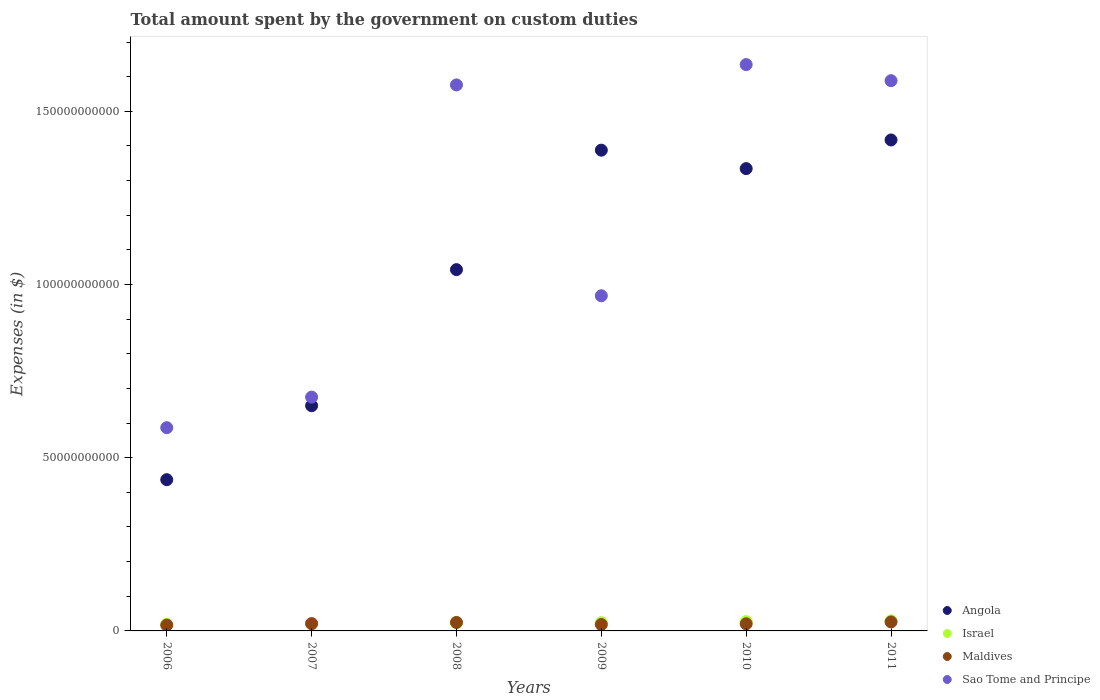How many different coloured dotlines are there?
Make the answer very short. 4. Is the number of dotlines equal to the number of legend labels?
Offer a terse response. Yes. What is the amount spent on custom duties by the government in Maldives in 2011?
Your answer should be very brief. 2.59e+09. Across all years, what is the maximum amount spent on custom duties by the government in Sao Tome and Principe?
Provide a succinct answer. 1.63e+11. Across all years, what is the minimum amount spent on custom duties by the government in Angola?
Your answer should be compact. 4.37e+1. In which year was the amount spent on custom duties by the government in Israel maximum?
Provide a short and direct response. 2011. What is the total amount spent on custom duties by the government in Maldives in the graph?
Make the answer very short. 1.27e+1. What is the difference between the amount spent on custom duties by the government in Israel in 2008 and that in 2011?
Offer a terse response. -5.37e+08. What is the difference between the amount spent on custom duties by the government in Israel in 2009 and the amount spent on custom duties by the government in Sao Tome and Principe in 2010?
Give a very brief answer. -1.61e+11. What is the average amount spent on custom duties by the government in Israel per year?
Give a very brief answer. 2.41e+09. In the year 2010, what is the difference between the amount spent on custom duties by the government in Angola and amount spent on custom duties by the government in Maldives?
Keep it short and to the point. 1.31e+11. What is the ratio of the amount spent on custom duties by the government in Maldives in 2007 to that in 2010?
Your response must be concise. 1.01. Is the difference between the amount spent on custom duties by the government in Angola in 2007 and 2010 greater than the difference between the amount spent on custom duties by the government in Maldives in 2007 and 2010?
Offer a very short reply. No. What is the difference between the highest and the second highest amount spent on custom duties by the government in Sao Tome and Principe?
Make the answer very short. 4.64e+09. What is the difference between the highest and the lowest amount spent on custom duties by the government in Israel?
Ensure brevity in your answer.  1.02e+09. Is the sum of the amount spent on custom duties by the government in Angola in 2007 and 2010 greater than the maximum amount spent on custom duties by the government in Sao Tome and Principe across all years?
Offer a terse response. Yes. Is it the case that in every year, the sum of the amount spent on custom duties by the government in Israel and amount spent on custom duties by the government in Sao Tome and Principe  is greater than the sum of amount spent on custom duties by the government in Maldives and amount spent on custom duties by the government in Angola?
Make the answer very short. Yes. Is it the case that in every year, the sum of the amount spent on custom duties by the government in Angola and amount spent on custom duties by the government in Sao Tome and Principe  is greater than the amount spent on custom duties by the government in Israel?
Ensure brevity in your answer.  Yes. Does the amount spent on custom duties by the government in Maldives monotonically increase over the years?
Provide a succinct answer. No. Is the amount spent on custom duties by the government in Sao Tome and Principe strictly less than the amount spent on custom duties by the government in Angola over the years?
Make the answer very short. No. What is the difference between two consecutive major ticks on the Y-axis?
Give a very brief answer. 5.00e+1. Does the graph contain grids?
Ensure brevity in your answer.  No. Where does the legend appear in the graph?
Your answer should be very brief. Bottom right. How are the legend labels stacked?
Your answer should be compact. Vertical. What is the title of the graph?
Offer a very short reply. Total amount spent by the government on custom duties. What is the label or title of the Y-axis?
Give a very brief answer. Expenses (in $). What is the Expenses (in $) of Angola in 2006?
Give a very brief answer. 4.37e+1. What is the Expenses (in $) in Israel in 2006?
Your response must be concise. 1.89e+09. What is the Expenses (in $) of Maldives in 2006?
Your answer should be compact. 1.68e+09. What is the Expenses (in $) in Sao Tome and Principe in 2006?
Your answer should be compact. 5.87e+1. What is the Expenses (in $) in Angola in 2007?
Offer a terse response. 6.50e+1. What is the Expenses (in $) of Israel in 2007?
Ensure brevity in your answer.  2.22e+09. What is the Expenses (in $) of Maldives in 2007?
Your response must be concise. 2.09e+09. What is the Expenses (in $) of Sao Tome and Principe in 2007?
Give a very brief answer. 6.75e+1. What is the Expenses (in $) in Angola in 2008?
Offer a very short reply. 1.04e+11. What is the Expenses (in $) of Israel in 2008?
Keep it short and to the point. 2.38e+09. What is the Expenses (in $) in Maldives in 2008?
Offer a terse response. 2.45e+09. What is the Expenses (in $) of Sao Tome and Principe in 2008?
Your answer should be very brief. 1.58e+11. What is the Expenses (in $) in Angola in 2009?
Your response must be concise. 1.39e+11. What is the Expenses (in $) of Israel in 2009?
Your response must be concise. 2.40e+09. What is the Expenses (in $) in Maldives in 2009?
Offer a very short reply. 1.85e+09. What is the Expenses (in $) in Sao Tome and Principe in 2009?
Your response must be concise. 9.67e+1. What is the Expenses (in $) of Angola in 2010?
Offer a very short reply. 1.33e+11. What is the Expenses (in $) of Israel in 2010?
Your response must be concise. 2.69e+09. What is the Expenses (in $) of Maldives in 2010?
Offer a terse response. 2.06e+09. What is the Expenses (in $) in Sao Tome and Principe in 2010?
Ensure brevity in your answer.  1.63e+11. What is the Expenses (in $) in Angola in 2011?
Provide a succinct answer. 1.42e+11. What is the Expenses (in $) in Israel in 2011?
Provide a short and direct response. 2.91e+09. What is the Expenses (in $) of Maldives in 2011?
Offer a very short reply. 2.59e+09. What is the Expenses (in $) in Sao Tome and Principe in 2011?
Keep it short and to the point. 1.59e+11. Across all years, what is the maximum Expenses (in $) in Angola?
Offer a very short reply. 1.42e+11. Across all years, what is the maximum Expenses (in $) of Israel?
Offer a terse response. 2.91e+09. Across all years, what is the maximum Expenses (in $) of Maldives?
Keep it short and to the point. 2.59e+09. Across all years, what is the maximum Expenses (in $) of Sao Tome and Principe?
Offer a terse response. 1.63e+11. Across all years, what is the minimum Expenses (in $) of Angola?
Provide a succinct answer. 4.37e+1. Across all years, what is the minimum Expenses (in $) of Israel?
Provide a succinct answer. 1.89e+09. Across all years, what is the minimum Expenses (in $) in Maldives?
Your response must be concise. 1.68e+09. Across all years, what is the minimum Expenses (in $) in Sao Tome and Principe?
Keep it short and to the point. 5.87e+1. What is the total Expenses (in $) of Angola in the graph?
Make the answer very short. 6.27e+11. What is the total Expenses (in $) in Israel in the graph?
Offer a very short reply. 1.45e+1. What is the total Expenses (in $) in Maldives in the graph?
Make the answer very short. 1.27e+1. What is the total Expenses (in $) in Sao Tome and Principe in the graph?
Your response must be concise. 7.03e+11. What is the difference between the Expenses (in $) of Angola in 2006 and that in 2007?
Offer a very short reply. -2.13e+1. What is the difference between the Expenses (in $) in Israel in 2006 and that in 2007?
Your response must be concise. -3.21e+08. What is the difference between the Expenses (in $) of Maldives in 2006 and that in 2007?
Offer a terse response. -4.02e+08. What is the difference between the Expenses (in $) of Sao Tome and Principe in 2006 and that in 2007?
Give a very brief answer. -8.83e+09. What is the difference between the Expenses (in $) in Angola in 2006 and that in 2008?
Offer a terse response. -6.06e+1. What is the difference between the Expenses (in $) in Israel in 2006 and that in 2008?
Give a very brief answer. -4.81e+08. What is the difference between the Expenses (in $) in Maldives in 2006 and that in 2008?
Provide a short and direct response. -7.65e+08. What is the difference between the Expenses (in $) of Sao Tome and Principe in 2006 and that in 2008?
Your answer should be very brief. -9.89e+1. What is the difference between the Expenses (in $) of Angola in 2006 and that in 2009?
Offer a very short reply. -9.51e+1. What is the difference between the Expenses (in $) of Israel in 2006 and that in 2009?
Give a very brief answer. -5.08e+08. What is the difference between the Expenses (in $) of Maldives in 2006 and that in 2009?
Ensure brevity in your answer.  -1.65e+08. What is the difference between the Expenses (in $) in Sao Tome and Principe in 2006 and that in 2009?
Offer a terse response. -3.81e+1. What is the difference between the Expenses (in $) of Angola in 2006 and that in 2010?
Your response must be concise. -8.98e+1. What is the difference between the Expenses (in $) in Israel in 2006 and that in 2010?
Your answer should be compact. -7.95e+08. What is the difference between the Expenses (in $) in Maldives in 2006 and that in 2010?
Offer a terse response. -3.72e+08. What is the difference between the Expenses (in $) in Sao Tome and Principe in 2006 and that in 2010?
Give a very brief answer. -1.05e+11. What is the difference between the Expenses (in $) in Angola in 2006 and that in 2011?
Keep it short and to the point. -9.81e+1. What is the difference between the Expenses (in $) in Israel in 2006 and that in 2011?
Give a very brief answer. -1.02e+09. What is the difference between the Expenses (in $) in Maldives in 2006 and that in 2011?
Your answer should be compact. -9.02e+08. What is the difference between the Expenses (in $) in Sao Tome and Principe in 2006 and that in 2011?
Offer a very short reply. -1.00e+11. What is the difference between the Expenses (in $) in Angola in 2007 and that in 2008?
Provide a succinct answer. -3.93e+1. What is the difference between the Expenses (in $) of Israel in 2007 and that in 2008?
Make the answer very short. -1.60e+08. What is the difference between the Expenses (in $) of Maldives in 2007 and that in 2008?
Your answer should be very brief. -3.62e+08. What is the difference between the Expenses (in $) in Sao Tome and Principe in 2007 and that in 2008?
Offer a terse response. -9.01e+1. What is the difference between the Expenses (in $) in Angola in 2007 and that in 2009?
Provide a succinct answer. -7.38e+1. What is the difference between the Expenses (in $) of Israel in 2007 and that in 2009?
Provide a short and direct response. -1.87e+08. What is the difference between the Expenses (in $) of Maldives in 2007 and that in 2009?
Your answer should be compact. 2.38e+08. What is the difference between the Expenses (in $) of Sao Tome and Principe in 2007 and that in 2009?
Offer a terse response. -2.93e+1. What is the difference between the Expenses (in $) in Angola in 2007 and that in 2010?
Keep it short and to the point. -6.84e+1. What is the difference between the Expenses (in $) of Israel in 2007 and that in 2010?
Your answer should be very brief. -4.74e+08. What is the difference between the Expenses (in $) of Maldives in 2007 and that in 2010?
Offer a terse response. 3.07e+07. What is the difference between the Expenses (in $) in Sao Tome and Principe in 2007 and that in 2010?
Keep it short and to the point. -9.60e+1. What is the difference between the Expenses (in $) in Angola in 2007 and that in 2011?
Your answer should be very brief. -7.67e+1. What is the difference between the Expenses (in $) in Israel in 2007 and that in 2011?
Your response must be concise. -6.97e+08. What is the difference between the Expenses (in $) in Maldives in 2007 and that in 2011?
Your answer should be compact. -5.00e+08. What is the difference between the Expenses (in $) in Sao Tome and Principe in 2007 and that in 2011?
Provide a short and direct response. -9.13e+1. What is the difference between the Expenses (in $) of Angola in 2008 and that in 2009?
Give a very brief answer. -3.45e+1. What is the difference between the Expenses (in $) of Israel in 2008 and that in 2009?
Keep it short and to the point. -2.70e+07. What is the difference between the Expenses (in $) in Maldives in 2008 and that in 2009?
Provide a short and direct response. 6.00e+08. What is the difference between the Expenses (in $) of Sao Tome and Principe in 2008 and that in 2009?
Provide a short and direct response. 6.09e+1. What is the difference between the Expenses (in $) in Angola in 2008 and that in 2010?
Provide a succinct answer. -2.92e+1. What is the difference between the Expenses (in $) in Israel in 2008 and that in 2010?
Provide a short and direct response. -3.14e+08. What is the difference between the Expenses (in $) in Maldives in 2008 and that in 2010?
Your answer should be compact. 3.93e+08. What is the difference between the Expenses (in $) in Sao Tome and Principe in 2008 and that in 2010?
Your answer should be compact. -5.86e+09. What is the difference between the Expenses (in $) in Angola in 2008 and that in 2011?
Provide a succinct answer. -3.74e+1. What is the difference between the Expenses (in $) in Israel in 2008 and that in 2011?
Provide a short and direct response. -5.37e+08. What is the difference between the Expenses (in $) of Maldives in 2008 and that in 2011?
Give a very brief answer. -1.38e+08. What is the difference between the Expenses (in $) in Sao Tome and Principe in 2008 and that in 2011?
Your answer should be compact. -1.22e+09. What is the difference between the Expenses (in $) in Angola in 2009 and that in 2010?
Provide a short and direct response. 5.33e+09. What is the difference between the Expenses (in $) of Israel in 2009 and that in 2010?
Offer a terse response. -2.87e+08. What is the difference between the Expenses (in $) in Maldives in 2009 and that in 2010?
Your answer should be compact. -2.07e+08. What is the difference between the Expenses (in $) in Sao Tome and Principe in 2009 and that in 2010?
Offer a very short reply. -6.67e+1. What is the difference between the Expenses (in $) in Angola in 2009 and that in 2011?
Your answer should be compact. -2.95e+09. What is the difference between the Expenses (in $) of Israel in 2009 and that in 2011?
Give a very brief answer. -5.10e+08. What is the difference between the Expenses (in $) in Maldives in 2009 and that in 2011?
Keep it short and to the point. -7.38e+08. What is the difference between the Expenses (in $) of Sao Tome and Principe in 2009 and that in 2011?
Your response must be concise. -6.21e+1. What is the difference between the Expenses (in $) of Angola in 2010 and that in 2011?
Your answer should be very brief. -8.27e+09. What is the difference between the Expenses (in $) of Israel in 2010 and that in 2011?
Offer a very short reply. -2.23e+08. What is the difference between the Expenses (in $) of Maldives in 2010 and that in 2011?
Make the answer very short. -5.31e+08. What is the difference between the Expenses (in $) in Sao Tome and Principe in 2010 and that in 2011?
Ensure brevity in your answer.  4.64e+09. What is the difference between the Expenses (in $) of Angola in 2006 and the Expenses (in $) of Israel in 2007?
Ensure brevity in your answer.  4.14e+1. What is the difference between the Expenses (in $) of Angola in 2006 and the Expenses (in $) of Maldives in 2007?
Give a very brief answer. 4.16e+1. What is the difference between the Expenses (in $) in Angola in 2006 and the Expenses (in $) in Sao Tome and Principe in 2007?
Ensure brevity in your answer.  -2.38e+1. What is the difference between the Expenses (in $) of Israel in 2006 and the Expenses (in $) of Maldives in 2007?
Give a very brief answer. -1.92e+08. What is the difference between the Expenses (in $) in Israel in 2006 and the Expenses (in $) in Sao Tome and Principe in 2007?
Offer a terse response. -6.56e+1. What is the difference between the Expenses (in $) of Maldives in 2006 and the Expenses (in $) of Sao Tome and Principe in 2007?
Your response must be concise. -6.58e+1. What is the difference between the Expenses (in $) of Angola in 2006 and the Expenses (in $) of Israel in 2008?
Your answer should be very brief. 4.13e+1. What is the difference between the Expenses (in $) in Angola in 2006 and the Expenses (in $) in Maldives in 2008?
Provide a short and direct response. 4.12e+1. What is the difference between the Expenses (in $) of Angola in 2006 and the Expenses (in $) of Sao Tome and Principe in 2008?
Keep it short and to the point. -1.14e+11. What is the difference between the Expenses (in $) of Israel in 2006 and the Expenses (in $) of Maldives in 2008?
Provide a succinct answer. -5.55e+08. What is the difference between the Expenses (in $) of Israel in 2006 and the Expenses (in $) of Sao Tome and Principe in 2008?
Provide a succinct answer. -1.56e+11. What is the difference between the Expenses (in $) in Maldives in 2006 and the Expenses (in $) in Sao Tome and Principe in 2008?
Your answer should be compact. -1.56e+11. What is the difference between the Expenses (in $) in Angola in 2006 and the Expenses (in $) in Israel in 2009?
Ensure brevity in your answer.  4.13e+1. What is the difference between the Expenses (in $) of Angola in 2006 and the Expenses (in $) of Maldives in 2009?
Provide a succinct answer. 4.18e+1. What is the difference between the Expenses (in $) in Angola in 2006 and the Expenses (in $) in Sao Tome and Principe in 2009?
Your answer should be compact. -5.31e+1. What is the difference between the Expenses (in $) of Israel in 2006 and the Expenses (in $) of Maldives in 2009?
Give a very brief answer. 4.52e+07. What is the difference between the Expenses (in $) of Israel in 2006 and the Expenses (in $) of Sao Tome and Principe in 2009?
Your answer should be compact. -9.49e+1. What is the difference between the Expenses (in $) of Maldives in 2006 and the Expenses (in $) of Sao Tome and Principe in 2009?
Keep it short and to the point. -9.51e+1. What is the difference between the Expenses (in $) in Angola in 2006 and the Expenses (in $) in Israel in 2010?
Give a very brief answer. 4.10e+1. What is the difference between the Expenses (in $) in Angola in 2006 and the Expenses (in $) in Maldives in 2010?
Offer a terse response. 4.16e+1. What is the difference between the Expenses (in $) in Angola in 2006 and the Expenses (in $) in Sao Tome and Principe in 2010?
Offer a very short reply. -1.20e+11. What is the difference between the Expenses (in $) in Israel in 2006 and the Expenses (in $) in Maldives in 2010?
Provide a succinct answer. -1.62e+08. What is the difference between the Expenses (in $) of Israel in 2006 and the Expenses (in $) of Sao Tome and Principe in 2010?
Provide a short and direct response. -1.62e+11. What is the difference between the Expenses (in $) of Maldives in 2006 and the Expenses (in $) of Sao Tome and Principe in 2010?
Offer a terse response. -1.62e+11. What is the difference between the Expenses (in $) in Angola in 2006 and the Expenses (in $) in Israel in 2011?
Offer a terse response. 4.07e+1. What is the difference between the Expenses (in $) of Angola in 2006 and the Expenses (in $) of Maldives in 2011?
Give a very brief answer. 4.11e+1. What is the difference between the Expenses (in $) in Angola in 2006 and the Expenses (in $) in Sao Tome and Principe in 2011?
Offer a very short reply. -1.15e+11. What is the difference between the Expenses (in $) of Israel in 2006 and the Expenses (in $) of Maldives in 2011?
Your answer should be compact. -6.92e+08. What is the difference between the Expenses (in $) of Israel in 2006 and the Expenses (in $) of Sao Tome and Principe in 2011?
Provide a short and direct response. -1.57e+11. What is the difference between the Expenses (in $) of Maldives in 2006 and the Expenses (in $) of Sao Tome and Principe in 2011?
Make the answer very short. -1.57e+11. What is the difference between the Expenses (in $) of Angola in 2007 and the Expenses (in $) of Israel in 2008?
Your response must be concise. 6.26e+1. What is the difference between the Expenses (in $) of Angola in 2007 and the Expenses (in $) of Maldives in 2008?
Your response must be concise. 6.26e+1. What is the difference between the Expenses (in $) in Angola in 2007 and the Expenses (in $) in Sao Tome and Principe in 2008?
Your answer should be compact. -9.26e+1. What is the difference between the Expenses (in $) in Israel in 2007 and the Expenses (in $) in Maldives in 2008?
Keep it short and to the point. -2.34e+08. What is the difference between the Expenses (in $) in Israel in 2007 and the Expenses (in $) in Sao Tome and Principe in 2008?
Offer a terse response. -1.55e+11. What is the difference between the Expenses (in $) of Maldives in 2007 and the Expenses (in $) of Sao Tome and Principe in 2008?
Keep it short and to the point. -1.56e+11. What is the difference between the Expenses (in $) of Angola in 2007 and the Expenses (in $) of Israel in 2009?
Your answer should be very brief. 6.26e+1. What is the difference between the Expenses (in $) of Angola in 2007 and the Expenses (in $) of Maldives in 2009?
Ensure brevity in your answer.  6.32e+1. What is the difference between the Expenses (in $) in Angola in 2007 and the Expenses (in $) in Sao Tome and Principe in 2009?
Give a very brief answer. -3.17e+1. What is the difference between the Expenses (in $) of Israel in 2007 and the Expenses (in $) of Maldives in 2009?
Give a very brief answer. 3.66e+08. What is the difference between the Expenses (in $) in Israel in 2007 and the Expenses (in $) in Sao Tome and Principe in 2009?
Make the answer very short. -9.45e+1. What is the difference between the Expenses (in $) of Maldives in 2007 and the Expenses (in $) of Sao Tome and Principe in 2009?
Offer a very short reply. -9.47e+1. What is the difference between the Expenses (in $) of Angola in 2007 and the Expenses (in $) of Israel in 2010?
Ensure brevity in your answer.  6.23e+1. What is the difference between the Expenses (in $) of Angola in 2007 and the Expenses (in $) of Maldives in 2010?
Your answer should be very brief. 6.30e+1. What is the difference between the Expenses (in $) in Angola in 2007 and the Expenses (in $) in Sao Tome and Principe in 2010?
Your response must be concise. -9.85e+1. What is the difference between the Expenses (in $) of Israel in 2007 and the Expenses (in $) of Maldives in 2010?
Ensure brevity in your answer.  1.59e+08. What is the difference between the Expenses (in $) in Israel in 2007 and the Expenses (in $) in Sao Tome and Principe in 2010?
Make the answer very short. -1.61e+11. What is the difference between the Expenses (in $) in Maldives in 2007 and the Expenses (in $) in Sao Tome and Principe in 2010?
Offer a very short reply. -1.61e+11. What is the difference between the Expenses (in $) in Angola in 2007 and the Expenses (in $) in Israel in 2011?
Your response must be concise. 6.21e+1. What is the difference between the Expenses (in $) in Angola in 2007 and the Expenses (in $) in Maldives in 2011?
Make the answer very short. 6.24e+1. What is the difference between the Expenses (in $) of Angola in 2007 and the Expenses (in $) of Sao Tome and Principe in 2011?
Make the answer very short. -9.38e+1. What is the difference between the Expenses (in $) of Israel in 2007 and the Expenses (in $) of Maldives in 2011?
Provide a succinct answer. -3.72e+08. What is the difference between the Expenses (in $) in Israel in 2007 and the Expenses (in $) in Sao Tome and Principe in 2011?
Offer a very short reply. -1.57e+11. What is the difference between the Expenses (in $) of Maldives in 2007 and the Expenses (in $) of Sao Tome and Principe in 2011?
Provide a succinct answer. -1.57e+11. What is the difference between the Expenses (in $) in Angola in 2008 and the Expenses (in $) in Israel in 2009?
Keep it short and to the point. 1.02e+11. What is the difference between the Expenses (in $) in Angola in 2008 and the Expenses (in $) in Maldives in 2009?
Give a very brief answer. 1.02e+11. What is the difference between the Expenses (in $) in Angola in 2008 and the Expenses (in $) in Sao Tome and Principe in 2009?
Your response must be concise. 7.54e+09. What is the difference between the Expenses (in $) in Israel in 2008 and the Expenses (in $) in Maldives in 2009?
Offer a terse response. 5.26e+08. What is the difference between the Expenses (in $) in Israel in 2008 and the Expenses (in $) in Sao Tome and Principe in 2009?
Your answer should be very brief. -9.44e+1. What is the difference between the Expenses (in $) of Maldives in 2008 and the Expenses (in $) of Sao Tome and Principe in 2009?
Provide a short and direct response. -9.43e+1. What is the difference between the Expenses (in $) of Angola in 2008 and the Expenses (in $) of Israel in 2010?
Make the answer very short. 1.02e+11. What is the difference between the Expenses (in $) in Angola in 2008 and the Expenses (in $) in Maldives in 2010?
Offer a very short reply. 1.02e+11. What is the difference between the Expenses (in $) of Angola in 2008 and the Expenses (in $) of Sao Tome and Principe in 2010?
Your response must be concise. -5.92e+1. What is the difference between the Expenses (in $) in Israel in 2008 and the Expenses (in $) in Maldives in 2010?
Keep it short and to the point. 3.19e+08. What is the difference between the Expenses (in $) of Israel in 2008 and the Expenses (in $) of Sao Tome and Principe in 2010?
Offer a terse response. -1.61e+11. What is the difference between the Expenses (in $) of Maldives in 2008 and the Expenses (in $) of Sao Tome and Principe in 2010?
Offer a terse response. -1.61e+11. What is the difference between the Expenses (in $) of Angola in 2008 and the Expenses (in $) of Israel in 2011?
Make the answer very short. 1.01e+11. What is the difference between the Expenses (in $) of Angola in 2008 and the Expenses (in $) of Maldives in 2011?
Keep it short and to the point. 1.02e+11. What is the difference between the Expenses (in $) in Angola in 2008 and the Expenses (in $) in Sao Tome and Principe in 2011?
Make the answer very short. -5.45e+1. What is the difference between the Expenses (in $) in Israel in 2008 and the Expenses (in $) in Maldives in 2011?
Offer a very short reply. -2.12e+08. What is the difference between the Expenses (in $) of Israel in 2008 and the Expenses (in $) of Sao Tome and Principe in 2011?
Offer a very short reply. -1.56e+11. What is the difference between the Expenses (in $) of Maldives in 2008 and the Expenses (in $) of Sao Tome and Principe in 2011?
Your answer should be very brief. -1.56e+11. What is the difference between the Expenses (in $) in Angola in 2009 and the Expenses (in $) in Israel in 2010?
Provide a succinct answer. 1.36e+11. What is the difference between the Expenses (in $) of Angola in 2009 and the Expenses (in $) of Maldives in 2010?
Give a very brief answer. 1.37e+11. What is the difference between the Expenses (in $) of Angola in 2009 and the Expenses (in $) of Sao Tome and Principe in 2010?
Provide a succinct answer. -2.47e+1. What is the difference between the Expenses (in $) in Israel in 2009 and the Expenses (in $) in Maldives in 2010?
Your answer should be very brief. 3.46e+08. What is the difference between the Expenses (in $) of Israel in 2009 and the Expenses (in $) of Sao Tome and Principe in 2010?
Ensure brevity in your answer.  -1.61e+11. What is the difference between the Expenses (in $) in Maldives in 2009 and the Expenses (in $) in Sao Tome and Principe in 2010?
Your response must be concise. -1.62e+11. What is the difference between the Expenses (in $) of Angola in 2009 and the Expenses (in $) of Israel in 2011?
Give a very brief answer. 1.36e+11. What is the difference between the Expenses (in $) in Angola in 2009 and the Expenses (in $) in Maldives in 2011?
Ensure brevity in your answer.  1.36e+11. What is the difference between the Expenses (in $) of Angola in 2009 and the Expenses (in $) of Sao Tome and Principe in 2011?
Provide a succinct answer. -2.01e+1. What is the difference between the Expenses (in $) in Israel in 2009 and the Expenses (in $) in Maldives in 2011?
Offer a very short reply. -1.84e+08. What is the difference between the Expenses (in $) in Israel in 2009 and the Expenses (in $) in Sao Tome and Principe in 2011?
Keep it short and to the point. -1.56e+11. What is the difference between the Expenses (in $) in Maldives in 2009 and the Expenses (in $) in Sao Tome and Principe in 2011?
Make the answer very short. -1.57e+11. What is the difference between the Expenses (in $) in Angola in 2010 and the Expenses (in $) in Israel in 2011?
Ensure brevity in your answer.  1.31e+11. What is the difference between the Expenses (in $) in Angola in 2010 and the Expenses (in $) in Maldives in 2011?
Your answer should be compact. 1.31e+11. What is the difference between the Expenses (in $) in Angola in 2010 and the Expenses (in $) in Sao Tome and Principe in 2011?
Make the answer very short. -2.54e+1. What is the difference between the Expenses (in $) of Israel in 2010 and the Expenses (in $) of Maldives in 2011?
Your response must be concise. 1.02e+08. What is the difference between the Expenses (in $) of Israel in 2010 and the Expenses (in $) of Sao Tome and Principe in 2011?
Provide a short and direct response. -1.56e+11. What is the difference between the Expenses (in $) in Maldives in 2010 and the Expenses (in $) in Sao Tome and Principe in 2011?
Offer a terse response. -1.57e+11. What is the average Expenses (in $) in Angola per year?
Offer a very short reply. 1.04e+11. What is the average Expenses (in $) of Israel per year?
Your answer should be compact. 2.41e+09. What is the average Expenses (in $) of Maldives per year?
Give a very brief answer. 2.12e+09. What is the average Expenses (in $) of Sao Tome and Principe per year?
Provide a short and direct response. 1.17e+11. In the year 2006, what is the difference between the Expenses (in $) in Angola and Expenses (in $) in Israel?
Your answer should be very brief. 4.18e+1. In the year 2006, what is the difference between the Expenses (in $) in Angola and Expenses (in $) in Maldives?
Provide a succinct answer. 4.20e+1. In the year 2006, what is the difference between the Expenses (in $) in Angola and Expenses (in $) in Sao Tome and Principe?
Provide a succinct answer. -1.50e+1. In the year 2006, what is the difference between the Expenses (in $) of Israel and Expenses (in $) of Maldives?
Offer a terse response. 2.10e+08. In the year 2006, what is the difference between the Expenses (in $) in Israel and Expenses (in $) in Sao Tome and Principe?
Your response must be concise. -5.68e+1. In the year 2006, what is the difference between the Expenses (in $) of Maldives and Expenses (in $) of Sao Tome and Principe?
Offer a very short reply. -5.70e+1. In the year 2007, what is the difference between the Expenses (in $) of Angola and Expenses (in $) of Israel?
Make the answer very short. 6.28e+1. In the year 2007, what is the difference between the Expenses (in $) in Angola and Expenses (in $) in Maldives?
Your answer should be very brief. 6.29e+1. In the year 2007, what is the difference between the Expenses (in $) of Angola and Expenses (in $) of Sao Tome and Principe?
Ensure brevity in your answer.  -2.49e+09. In the year 2007, what is the difference between the Expenses (in $) in Israel and Expenses (in $) in Maldives?
Offer a terse response. 1.28e+08. In the year 2007, what is the difference between the Expenses (in $) of Israel and Expenses (in $) of Sao Tome and Principe?
Keep it short and to the point. -6.53e+1. In the year 2007, what is the difference between the Expenses (in $) of Maldives and Expenses (in $) of Sao Tome and Principe?
Offer a very short reply. -6.54e+1. In the year 2008, what is the difference between the Expenses (in $) in Angola and Expenses (in $) in Israel?
Your answer should be compact. 1.02e+11. In the year 2008, what is the difference between the Expenses (in $) of Angola and Expenses (in $) of Maldives?
Make the answer very short. 1.02e+11. In the year 2008, what is the difference between the Expenses (in $) in Angola and Expenses (in $) in Sao Tome and Principe?
Make the answer very short. -5.33e+1. In the year 2008, what is the difference between the Expenses (in $) of Israel and Expenses (in $) of Maldives?
Provide a short and direct response. -7.38e+07. In the year 2008, what is the difference between the Expenses (in $) of Israel and Expenses (in $) of Sao Tome and Principe?
Provide a short and direct response. -1.55e+11. In the year 2008, what is the difference between the Expenses (in $) of Maldives and Expenses (in $) of Sao Tome and Principe?
Your answer should be very brief. -1.55e+11. In the year 2009, what is the difference between the Expenses (in $) in Angola and Expenses (in $) in Israel?
Your answer should be compact. 1.36e+11. In the year 2009, what is the difference between the Expenses (in $) in Angola and Expenses (in $) in Maldives?
Offer a terse response. 1.37e+11. In the year 2009, what is the difference between the Expenses (in $) in Angola and Expenses (in $) in Sao Tome and Principe?
Offer a terse response. 4.20e+1. In the year 2009, what is the difference between the Expenses (in $) in Israel and Expenses (in $) in Maldives?
Offer a very short reply. 5.53e+08. In the year 2009, what is the difference between the Expenses (in $) of Israel and Expenses (in $) of Sao Tome and Principe?
Ensure brevity in your answer.  -9.43e+1. In the year 2009, what is the difference between the Expenses (in $) of Maldives and Expenses (in $) of Sao Tome and Principe?
Provide a succinct answer. -9.49e+1. In the year 2010, what is the difference between the Expenses (in $) in Angola and Expenses (in $) in Israel?
Give a very brief answer. 1.31e+11. In the year 2010, what is the difference between the Expenses (in $) of Angola and Expenses (in $) of Maldives?
Make the answer very short. 1.31e+11. In the year 2010, what is the difference between the Expenses (in $) in Angola and Expenses (in $) in Sao Tome and Principe?
Give a very brief answer. -3.00e+1. In the year 2010, what is the difference between the Expenses (in $) in Israel and Expenses (in $) in Maldives?
Offer a very short reply. 6.33e+08. In the year 2010, what is the difference between the Expenses (in $) of Israel and Expenses (in $) of Sao Tome and Principe?
Make the answer very short. -1.61e+11. In the year 2010, what is the difference between the Expenses (in $) of Maldives and Expenses (in $) of Sao Tome and Principe?
Give a very brief answer. -1.61e+11. In the year 2011, what is the difference between the Expenses (in $) in Angola and Expenses (in $) in Israel?
Provide a succinct answer. 1.39e+11. In the year 2011, what is the difference between the Expenses (in $) in Angola and Expenses (in $) in Maldives?
Offer a very short reply. 1.39e+11. In the year 2011, what is the difference between the Expenses (in $) in Angola and Expenses (in $) in Sao Tome and Principe?
Keep it short and to the point. -1.71e+1. In the year 2011, what is the difference between the Expenses (in $) in Israel and Expenses (in $) in Maldives?
Offer a very short reply. 3.26e+08. In the year 2011, what is the difference between the Expenses (in $) in Israel and Expenses (in $) in Sao Tome and Principe?
Make the answer very short. -1.56e+11. In the year 2011, what is the difference between the Expenses (in $) in Maldives and Expenses (in $) in Sao Tome and Principe?
Provide a short and direct response. -1.56e+11. What is the ratio of the Expenses (in $) of Angola in 2006 to that in 2007?
Provide a short and direct response. 0.67. What is the ratio of the Expenses (in $) of Israel in 2006 to that in 2007?
Provide a short and direct response. 0.86. What is the ratio of the Expenses (in $) of Maldives in 2006 to that in 2007?
Your answer should be compact. 0.81. What is the ratio of the Expenses (in $) of Sao Tome and Principe in 2006 to that in 2007?
Offer a very short reply. 0.87. What is the ratio of the Expenses (in $) in Angola in 2006 to that in 2008?
Ensure brevity in your answer.  0.42. What is the ratio of the Expenses (in $) of Israel in 2006 to that in 2008?
Keep it short and to the point. 0.8. What is the ratio of the Expenses (in $) of Maldives in 2006 to that in 2008?
Offer a terse response. 0.69. What is the ratio of the Expenses (in $) of Sao Tome and Principe in 2006 to that in 2008?
Your answer should be compact. 0.37. What is the ratio of the Expenses (in $) in Angola in 2006 to that in 2009?
Your answer should be compact. 0.31. What is the ratio of the Expenses (in $) of Israel in 2006 to that in 2009?
Provide a short and direct response. 0.79. What is the ratio of the Expenses (in $) of Maldives in 2006 to that in 2009?
Provide a succinct answer. 0.91. What is the ratio of the Expenses (in $) of Sao Tome and Principe in 2006 to that in 2009?
Offer a very short reply. 0.61. What is the ratio of the Expenses (in $) in Angola in 2006 to that in 2010?
Keep it short and to the point. 0.33. What is the ratio of the Expenses (in $) in Israel in 2006 to that in 2010?
Make the answer very short. 0.7. What is the ratio of the Expenses (in $) in Maldives in 2006 to that in 2010?
Ensure brevity in your answer.  0.82. What is the ratio of the Expenses (in $) of Sao Tome and Principe in 2006 to that in 2010?
Ensure brevity in your answer.  0.36. What is the ratio of the Expenses (in $) in Angola in 2006 to that in 2011?
Your answer should be compact. 0.31. What is the ratio of the Expenses (in $) of Israel in 2006 to that in 2011?
Provide a succinct answer. 0.65. What is the ratio of the Expenses (in $) of Maldives in 2006 to that in 2011?
Your answer should be very brief. 0.65. What is the ratio of the Expenses (in $) of Sao Tome and Principe in 2006 to that in 2011?
Provide a succinct answer. 0.37. What is the ratio of the Expenses (in $) in Angola in 2007 to that in 2008?
Your answer should be compact. 0.62. What is the ratio of the Expenses (in $) of Israel in 2007 to that in 2008?
Keep it short and to the point. 0.93. What is the ratio of the Expenses (in $) of Maldives in 2007 to that in 2008?
Keep it short and to the point. 0.85. What is the ratio of the Expenses (in $) of Sao Tome and Principe in 2007 to that in 2008?
Make the answer very short. 0.43. What is the ratio of the Expenses (in $) in Angola in 2007 to that in 2009?
Keep it short and to the point. 0.47. What is the ratio of the Expenses (in $) in Israel in 2007 to that in 2009?
Ensure brevity in your answer.  0.92. What is the ratio of the Expenses (in $) of Maldives in 2007 to that in 2009?
Provide a short and direct response. 1.13. What is the ratio of the Expenses (in $) of Sao Tome and Principe in 2007 to that in 2009?
Your answer should be very brief. 0.7. What is the ratio of the Expenses (in $) of Angola in 2007 to that in 2010?
Your response must be concise. 0.49. What is the ratio of the Expenses (in $) of Israel in 2007 to that in 2010?
Make the answer very short. 0.82. What is the ratio of the Expenses (in $) of Maldives in 2007 to that in 2010?
Provide a succinct answer. 1.01. What is the ratio of the Expenses (in $) in Sao Tome and Principe in 2007 to that in 2010?
Ensure brevity in your answer.  0.41. What is the ratio of the Expenses (in $) of Angola in 2007 to that in 2011?
Make the answer very short. 0.46. What is the ratio of the Expenses (in $) of Israel in 2007 to that in 2011?
Offer a very short reply. 0.76. What is the ratio of the Expenses (in $) in Maldives in 2007 to that in 2011?
Make the answer very short. 0.81. What is the ratio of the Expenses (in $) in Sao Tome and Principe in 2007 to that in 2011?
Your answer should be very brief. 0.42. What is the ratio of the Expenses (in $) of Angola in 2008 to that in 2009?
Make the answer very short. 0.75. What is the ratio of the Expenses (in $) of Maldives in 2008 to that in 2009?
Your answer should be very brief. 1.32. What is the ratio of the Expenses (in $) in Sao Tome and Principe in 2008 to that in 2009?
Your answer should be compact. 1.63. What is the ratio of the Expenses (in $) in Angola in 2008 to that in 2010?
Ensure brevity in your answer.  0.78. What is the ratio of the Expenses (in $) in Israel in 2008 to that in 2010?
Provide a short and direct response. 0.88. What is the ratio of the Expenses (in $) in Maldives in 2008 to that in 2010?
Provide a succinct answer. 1.19. What is the ratio of the Expenses (in $) in Sao Tome and Principe in 2008 to that in 2010?
Make the answer very short. 0.96. What is the ratio of the Expenses (in $) of Angola in 2008 to that in 2011?
Give a very brief answer. 0.74. What is the ratio of the Expenses (in $) of Israel in 2008 to that in 2011?
Keep it short and to the point. 0.82. What is the ratio of the Expenses (in $) in Maldives in 2008 to that in 2011?
Offer a very short reply. 0.95. What is the ratio of the Expenses (in $) of Angola in 2009 to that in 2010?
Offer a terse response. 1.04. What is the ratio of the Expenses (in $) of Israel in 2009 to that in 2010?
Keep it short and to the point. 0.89. What is the ratio of the Expenses (in $) of Maldives in 2009 to that in 2010?
Your response must be concise. 0.9. What is the ratio of the Expenses (in $) in Sao Tome and Principe in 2009 to that in 2010?
Your answer should be very brief. 0.59. What is the ratio of the Expenses (in $) of Angola in 2009 to that in 2011?
Your answer should be very brief. 0.98. What is the ratio of the Expenses (in $) in Israel in 2009 to that in 2011?
Offer a terse response. 0.82. What is the ratio of the Expenses (in $) of Maldives in 2009 to that in 2011?
Offer a terse response. 0.71. What is the ratio of the Expenses (in $) in Sao Tome and Principe in 2009 to that in 2011?
Keep it short and to the point. 0.61. What is the ratio of the Expenses (in $) in Angola in 2010 to that in 2011?
Keep it short and to the point. 0.94. What is the ratio of the Expenses (in $) of Israel in 2010 to that in 2011?
Your response must be concise. 0.92. What is the ratio of the Expenses (in $) in Maldives in 2010 to that in 2011?
Provide a short and direct response. 0.79. What is the ratio of the Expenses (in $) in Sao Tome and Principe in 2010 to that in 2011?
Give a very brief answer. 1.03. What is the difference between the highest and the second highest Expenses (in $) of Angola?
Your answer should be compact. 2.95e+09. What is the difference between the highest and the second highest Expenses (in $) of Israel?
Your answer should be compact. 2.23e+08. What is the difference between the highest and the second highest Expenses (in $) of Maldives?
Keep it short and to the point. 1.38e+08. What is the difference between the highest and the second highest Expenses (in $) in Sao Tome and Principe?
Ensure brevity in your answer.  4.64e+09. What is the difference between the highest and the lowest Expenses (in $) of Angola?
Your answer should be compact. 9.81e+1. What is the difference between the highest and the lowest Expenses (in $) in Israel?
Your answer should be compact. 1.02e+09. What is the difference between the highest and the lowest Expenses (in $) of Maldives?
Make the answer very short. 9.02e+08. What is the difference between the highest and the lowest Expenses (in $) in Sao Tome and Principe?
Ensure brevity in your answer.  1.05e+11. 